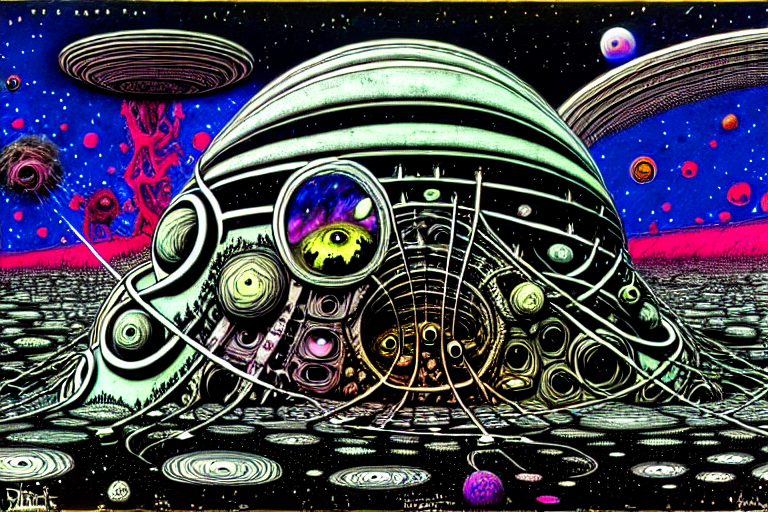What could the various celestial bodies in the background represent? The celestial bodies might symbolize the vastness and mystery of the universe, inviting viewers to consider themes of exploration, infinity, and the unknown. Each planet and star could serve as a metaphor for different realms of possibility or states of being. Does the artwork convey a sense of motion or stillness? The artwork conveys a sense of motion through swirling patterns, dynamic lines, and the impression of orbiting planets, which collectively evoke a feeling of cosmic fluidity and perpetual change within an expansive space. 